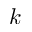Convert formula to latex. <formula><loc_0><loc_0><loc_500><loc_500>k</formula> 